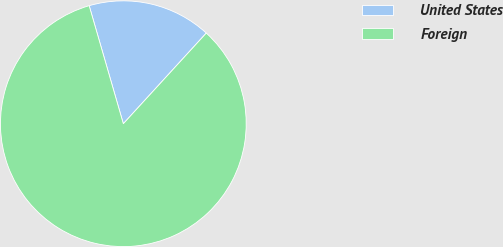<chart> <loc_0><loc_0><loc_500><loc_500><pie_chart><fcel>United States<fcel>Foreign<nl><fcel>16.28%<fcel>83.72%<nl></chart> 